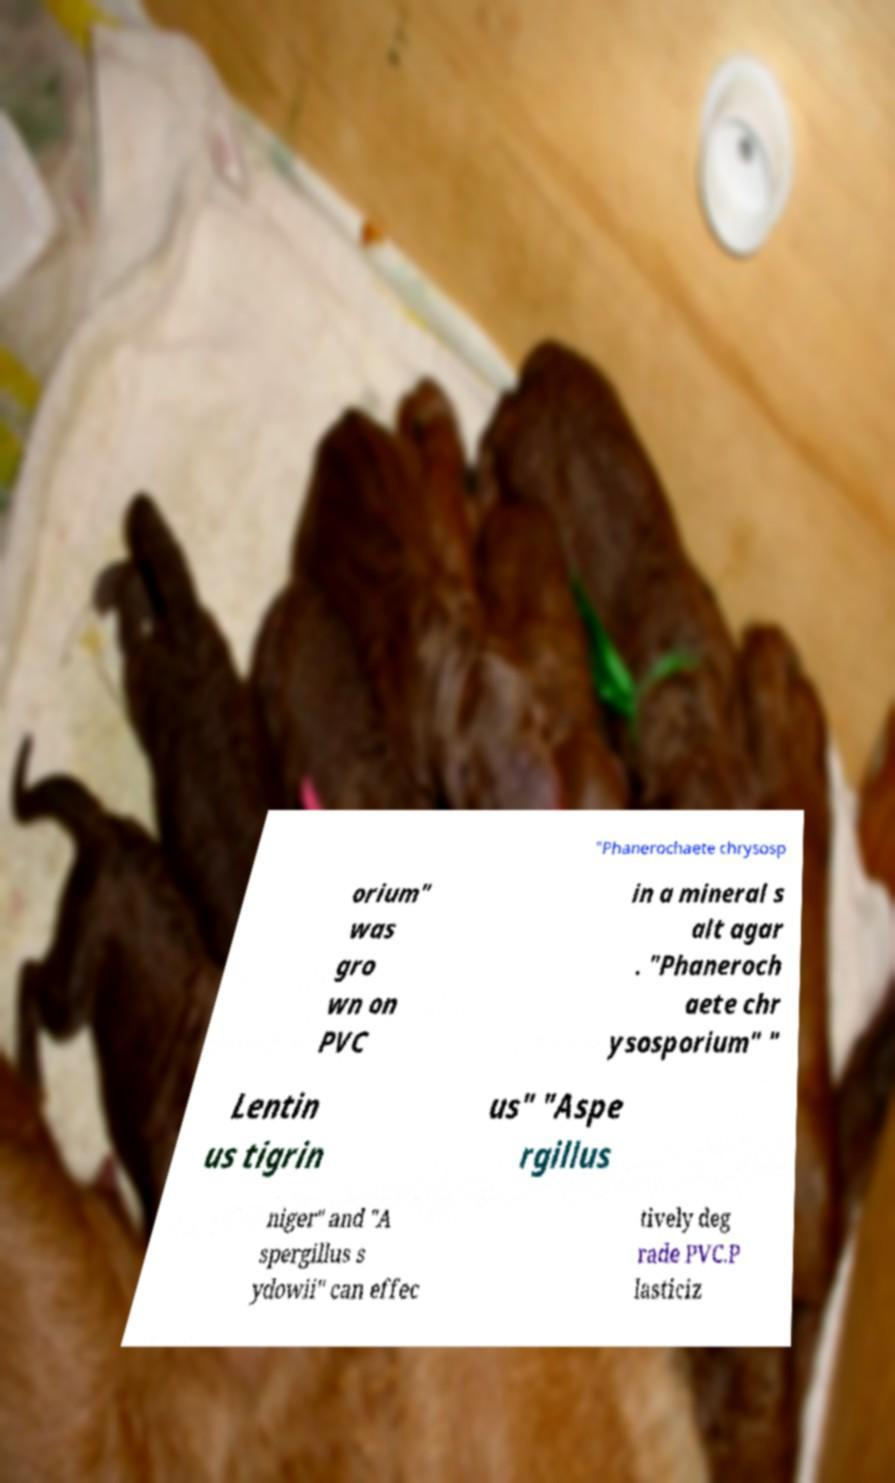For documentation purposes, I need the text within this image transcribed. Could you provide that? "Phanerochaete chrysosp orium" was gro wn on PVC in a mineral s alt agar . "Phaneroch aete chr ysosporium" " Lentin us tigrin us" "Aspe rgillus niger" and "A spergillus s ydowii" can effec tively deg rade PVC.P lasticiz 